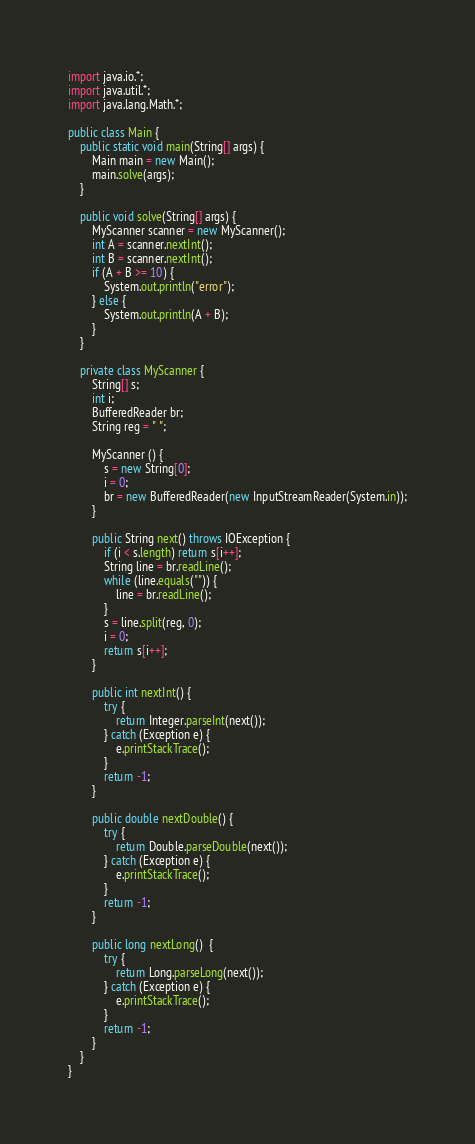Convert code to text. <code><loc_0><loc_0><loc_500><loc_500><_Java_>import java.io.*;
import java.util.*;
import java.lang.Math.*;

public class Main {
    public static void main(String[] args) {
        Main main = new Main();
        main.solve(args);
    }

    public void solve(String[] args) {
        MyScanner scanner = new MyScanner();
        int A = scanner.nextInt();
        int B = scanner.nextInt();
        if (A + B >= 10) {
            System.out.println("error");
        } else {
            System.out.println(A + B);
        }
    }

    private class MyScanner {
        String[] s;
        int i;
        BufferedReader br;
        String reg = " ";

        MyScanner () {
            s = new String[0];
            i = 0;
            br = new BufferedReader(new InputStreamReader(System.in));
        }

        public String next() throws IOException {
            if (i < s.length) return s[i++];
            String line = br.readLine();
            while (line.equals("")) {
                line = br.readLine();
            }
            s = line.split(reg, 0);
            i = 0;
            return s[i++];
        }

        public int nextInt() {
            try {
                return Integer.parseInt(next());
            } catch (Exception e) {
                e.printStackTrace();
            }
            return -1;
        }

        public double nextDouble() {
            try {
                return Double.parseDouble(next());
            } catch (Exception e) {
                e.printStackTrace();
            }
            return -1;
        }

        public long nextLong()  {
            try {
                return Long.parseLong(next());
            } catch (Exception e) {
                e.printStackTrace();
            }
            return -1;
        }
    }
}
</code> 